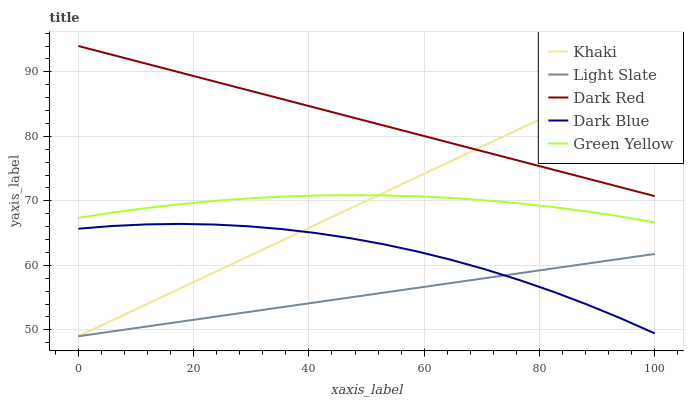Does Light Slate have the minimum area under the curve?
Answer yes or no. Yes. Does Dark Red have the maximum area under the curve?
Answer yes or no. Yes. Does Green Yellow have the minimum area under the curve?
Answer yes or no. No. Does Green Yellow have the maximum area under the curve?
Answer yes or no. No. Is Khaki the smoothest?
Answer yes or no. Yes. Is Dark Blue the roughest?
Answer yes or no. Yes. Is Dark Red the smoothest?
Answer yes or no. No. Is Dark Red the roughest?
Answer yes or no. No. Does Light Slate have the lowest value?
Answer yes or no. Yes. Does Green Yellow have the lowest value?
Answer yes or no. No. Does Dark Red have the highest value?
Answer yes or no. Yes. Does Green Yellow have the highest value?
Answer yes or no. No. Is Light Slate less than Green Yellow?
Answer yes or no. Yes. Is Dark Red greater than Dark Blue?
Answer yes or no. Yes. Does Green Yellow intersect Khaki?
Answer yes or no. Yes. Is Green Yellow less than Khaki?
Answer yes or no. No. Is Green Yellow greater than Khaki?
Answer yes or no. No. Does Light Slate intersect Green Yellow?
Answer yes or no. No. 